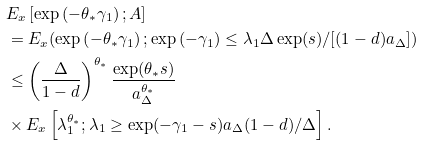Convert formula to latex. <formula><loc_0><loc_0><loc_500><loc_500>& E _ { x } \left [ \exp \left ( - \theta _ { \ast } \gamma _ { 1 } \right ) ; A \right ] \\ & = E _ { x } ( \exp \left ( - \theta _ { \ast } \gamma _ { 1 } \right ) ; \exp \left ( - \gamma _ { 1 } \right ) \leq \lambda _ { 1 } \Delta \exp ( s ) / [ ( 1 - d ) a _ { \Delta } ] ) \\ & \leq \left ( \frac { \Delta } { 1 - d } \right ) ^ { \theta _ { \ast } } \frac { \exp ( \theta _ { \ast } s ) } { a _ { \Delta } ^ { \theta _ { \ast } } } \\ & \times E _ { x } \left [ \lambda _ { 1 } ^ { \theta _ { \ast } } ; \lambda _ { 1 } \geq \exp ( - \gamma _ { 1 } - s ) a _ { \Delta } ( 1 - d ) / \Delta \right ] .</formula> 